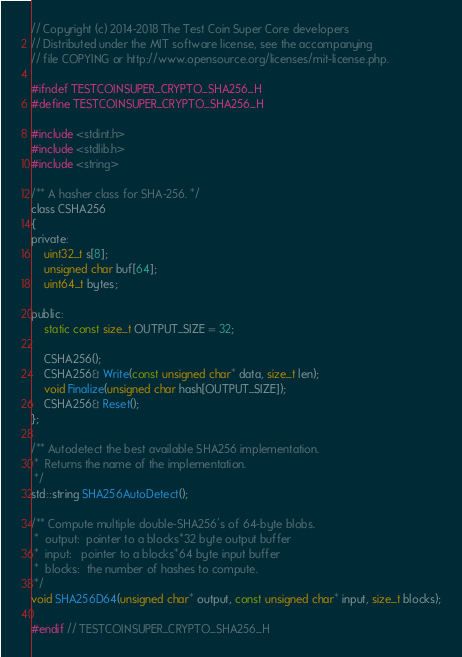Convert code to text. <code><loc_0><loc_0><loc_500><loc_500><_C_>// Copyright (c) 2014-2018 The Test Coin Super Core developers
// Distributed under the MIT software license, see the accompanying
// file COPYING or http://www.opensource.org/licenses/mit-license.php.

#ifndef TESTCOINSUPER_CRYPTO_SHA256_H
#define TESTCOINSUPER_CRYPTO_SHA256_H

#include <stdint.h>
#include <stdlib.h>
#include <string>

/** A hasher class for SHA-256. */
class CSHA256
{
private:
    uint32_t s[8];
    unsigned char buf[64];
    uint64_t bytes;

public:
    static const size_t OUTPUT_SIZE = 32;

    CSHA256();
    CSHA256& Write(const unsigned char* data, size_t len);
    void Finalize(unsigned char hash[OUTPUT_SIZE]);
    CSHA256& Reset();
};

/** Autodetect the best available SHA256 implementation.
 *  Returns the name of the implementation.
 */
std::string SHA256AutoDetect();

/** Compute multiple double-SHA256's of 64-byte blobs.
 *  output:  pointer to a blocks*32 byte output buffer
 *  input:   pointer to a blocks*64 byte input buffer
 *  blocks:  the number of hashes to compute.
 */
void SHA256D64(unsigned char* output, const unsigned char* input, size_t blocks);

#endif // TESTCOINSUPER_CRYPTO_SHA256_H
</code> 